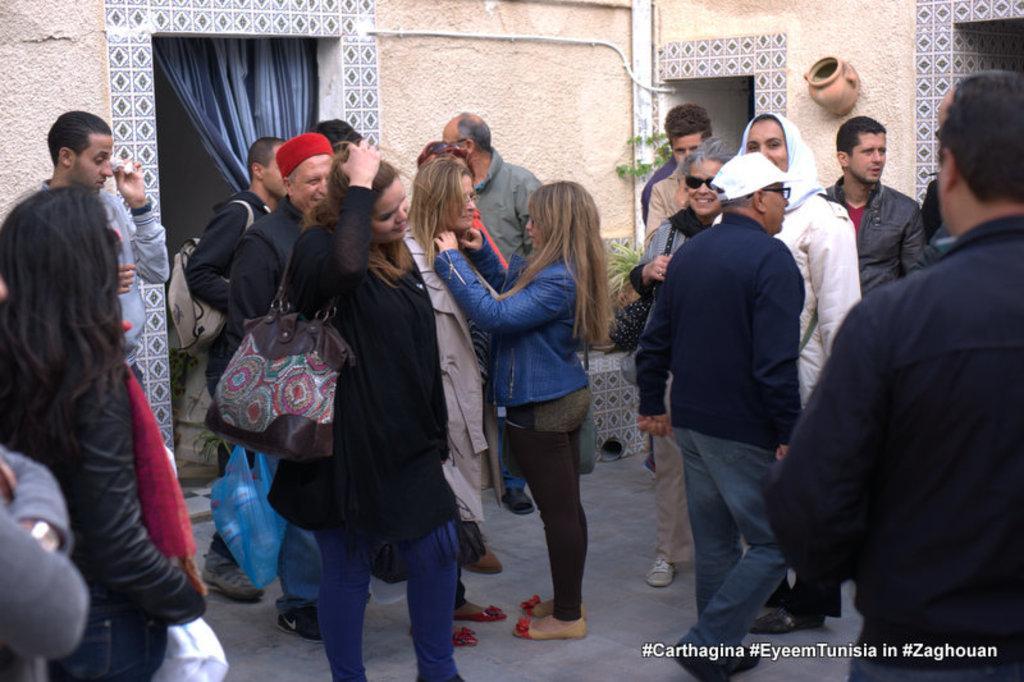Can you describe this image briefly? In this picture I can observe some people standing on the floor. There are men and women in this picture. Some of them are smiling. On the left side I can observe blue color curtain. In the background there is a wall. 